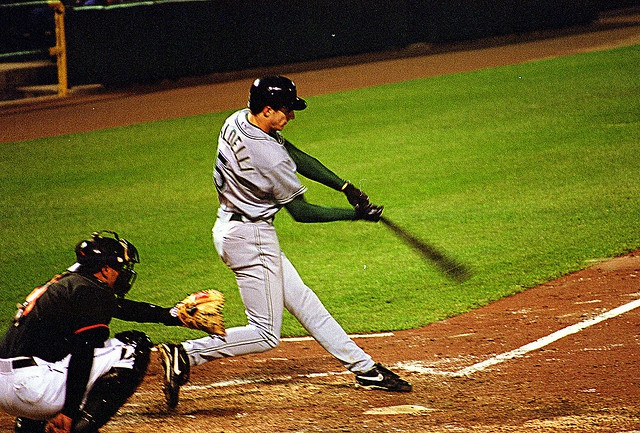Describe the objects in this image and their specific colors. I can see people in black, lightgray, darkgray, and beige tones, people in black, white, maroon, and olive tones, baseball glove in black, orange, gold, and brown tones, and baseball bat in black, olive, maroon, and darkgreen tones in this image. 